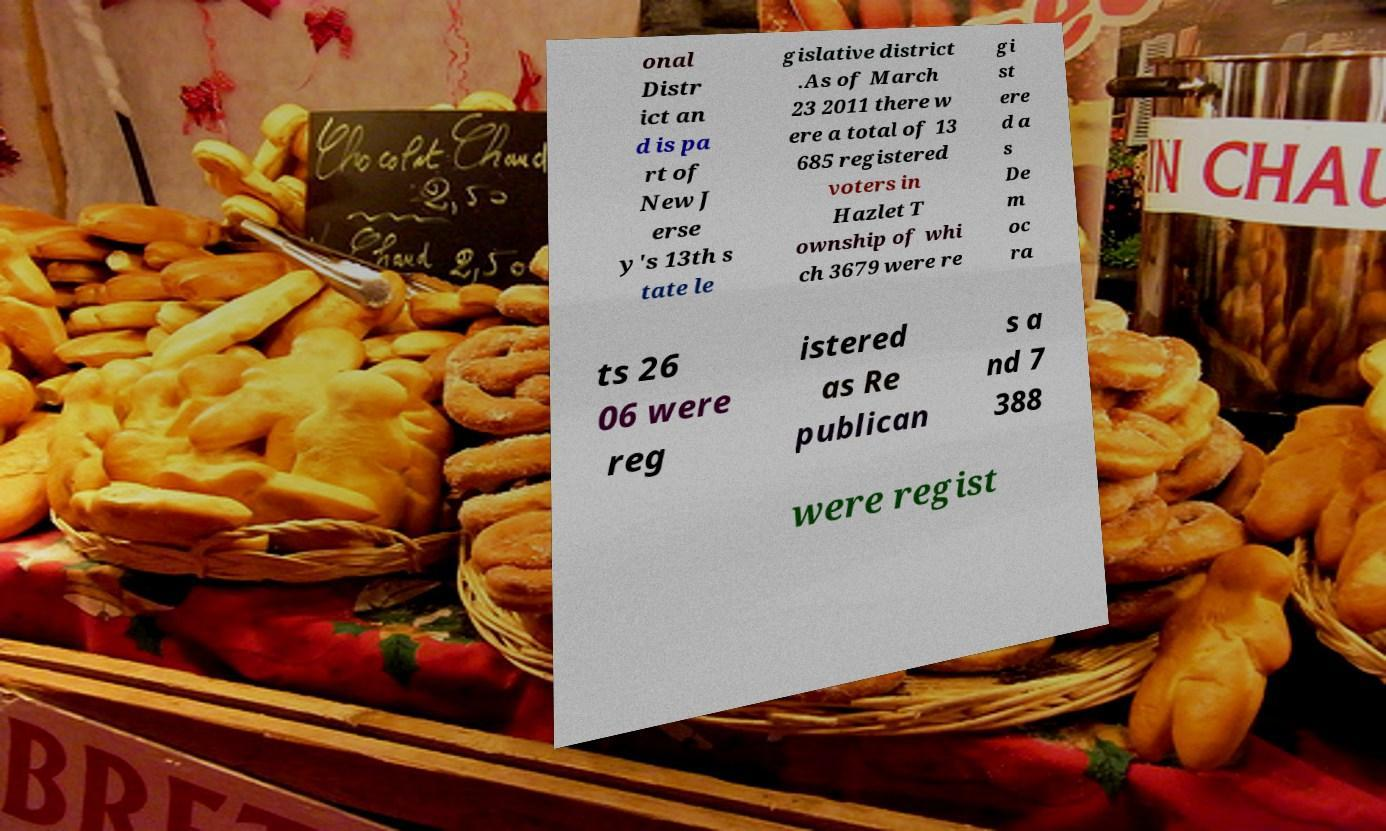Can you accurately transcribe the text from the provided image for me? onal Distr ict an d is pa rt of New J erse y's 13th s tate le gislative district .As of March 23 2011 there w ere a total of 13 685 registered voters in Hazlet T ownship of whi ch 3679 were re gi st ere d a s De m oc ra ts 26 06 were reg istered as Re publican s a nd 7 388 were regist 